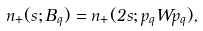Convert formula to latex. <formula><loc_0><loc_0><loc_500><loc_500>n _ { + } ( s ; B _ { q } ) = n _ { + } ( 2 s ; p _ { q } W p _ { q } ) ,</formula> 